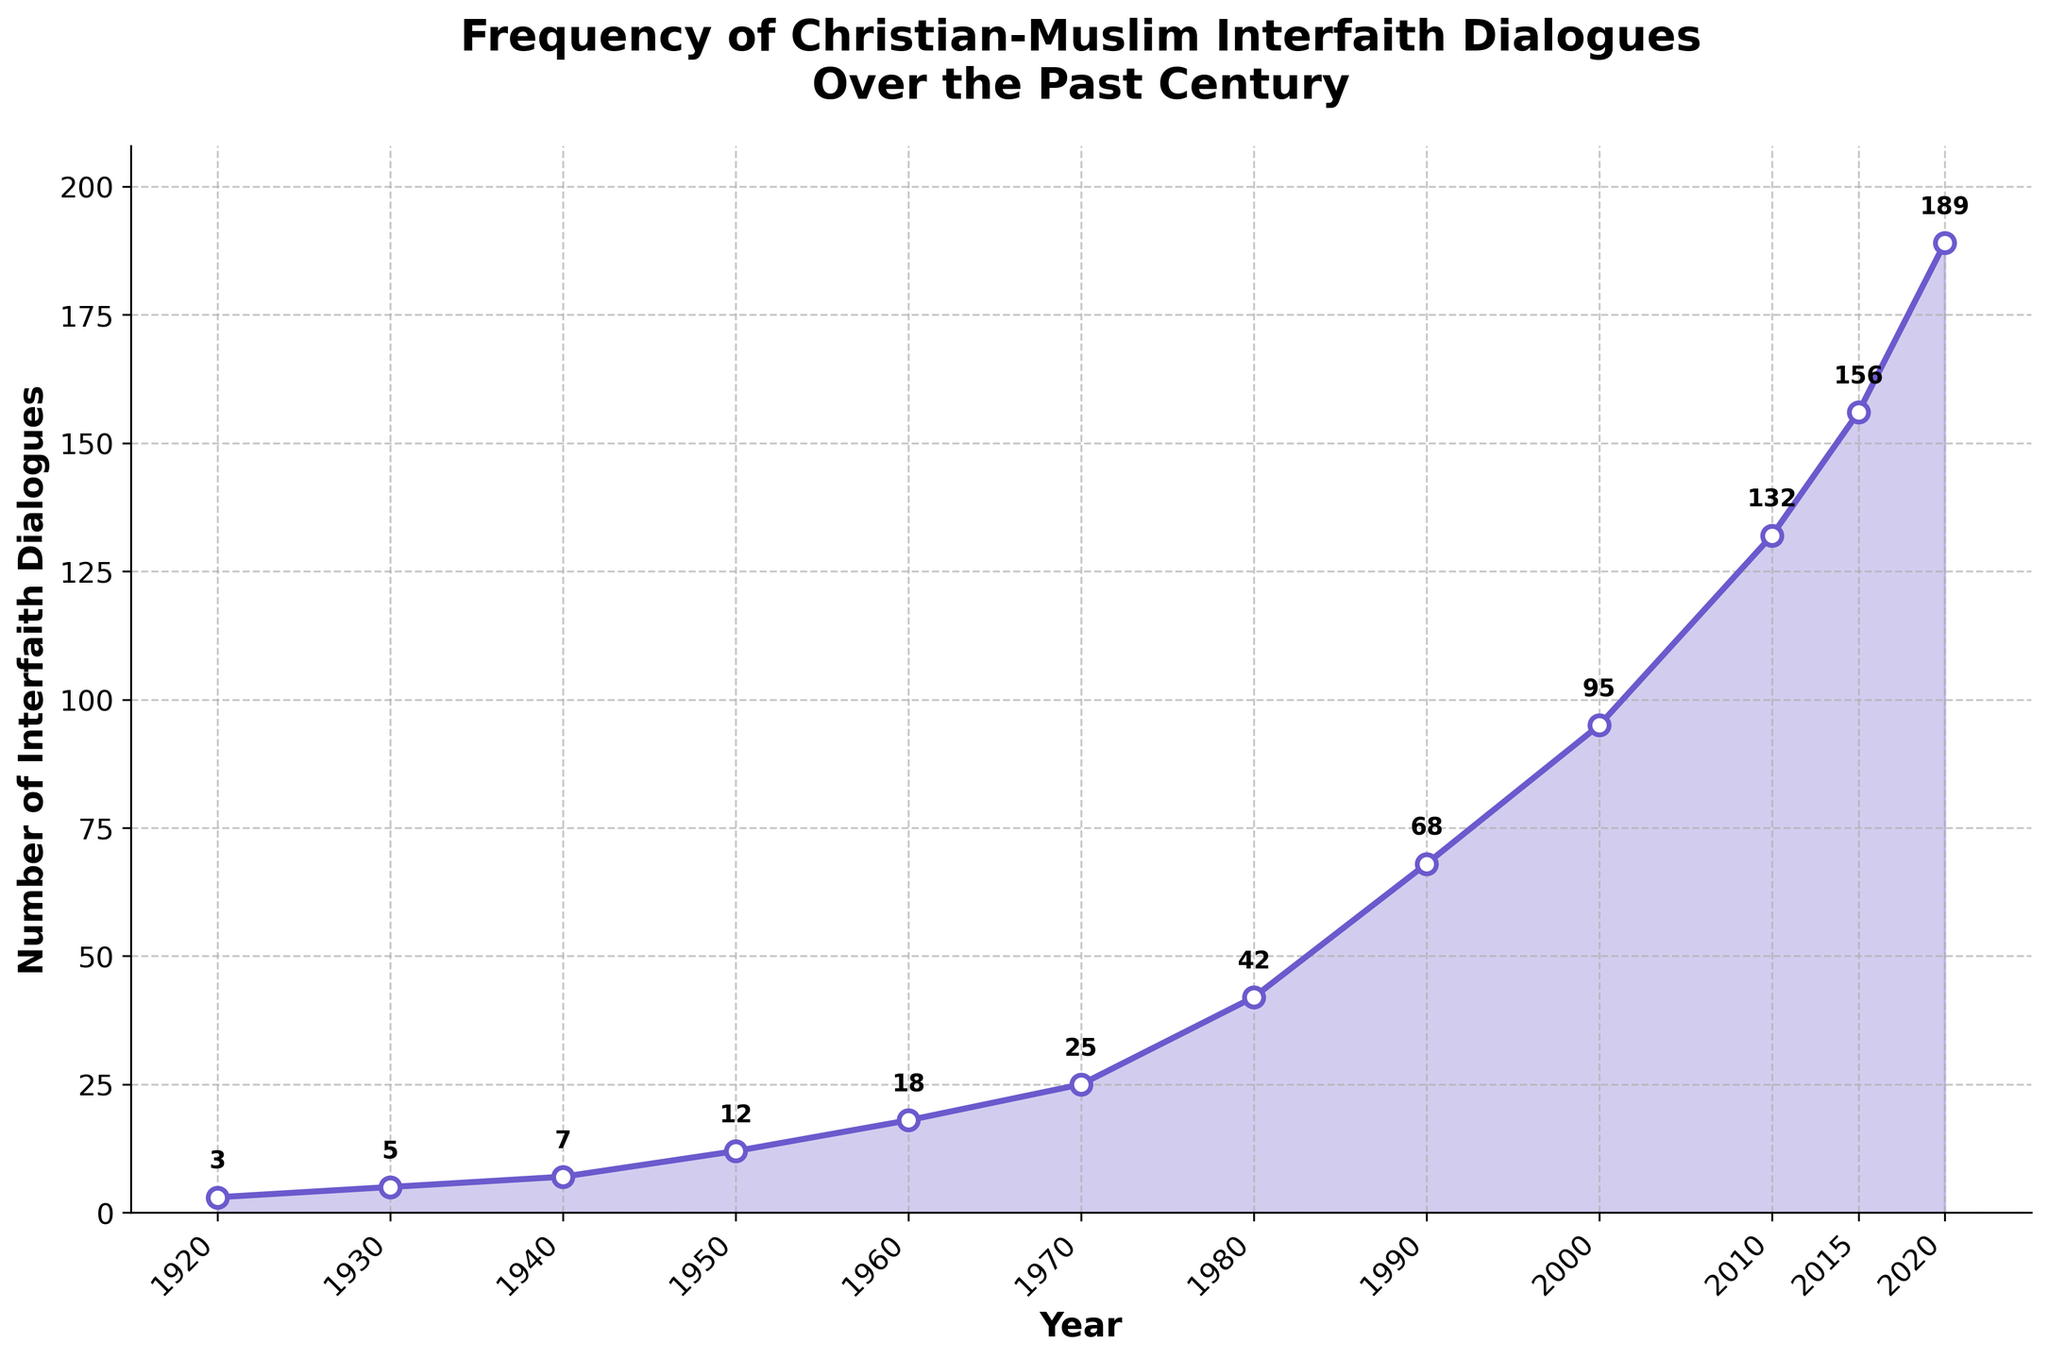What is the total number of interfaith dialogues recorded from 1920 to 2020? Summing up all the values in the 'Interfaith Dialogues' column: 3 + 5 + 7 + 12 + 18 + 25 + 42 + 68 + 95 + 132 + 156 + 189 = 752.
Answer: 752 Which decade saw the greatest increase in the number of interfaith dialogues? By how much did it increase? Checking the increase in each decade: 1930-1920 = 5-3 = 2, 1940-1930 = 7-5 = 2, 1950-1940 = 12-7 = 5, 1960-1950 = 18-12 = 6, 1970-1960 = 25-18 = 7, 1980-1970 = 42-25 = 17, 1990-1980 = 68-42 = 26, 2000-1990 = 95-68 = 27, 2010-2000 = 132-95 = 37, 2015-2010 = 156-132 = 24, 2020-2015 = 189-156 = 33. The greatest increase occurred from 2010 to 2015 with an increase of 24 dialogues.
Answer: 2010-2015, 24 How has the trend of interfaith dialogues changed between 1950 and 1980? From the graph, the dialogues in 1950 are 12, in 1960 are 18, in 1970 are 25, and in 1980 are 42. This shows a steady increase each decade: 1950-1960 = 18-12 = 6, 1960-1970 = 25-18 = 7, 1970-1980 = 42-25 = 17. So, there's a positive upward trend, with an increasing rate over the decades.
Answer: Increasing What was the percentage increase in interfaith dialogues from 2000 to 2020? Dialogues in 2000 = 95, dialogues in 2020 = 189. Percentage increase = ((189 - 95) / 95) * 100 = (94 / 95) * 100 ≈ 98.95%.
Answer: ≈ 98.95% What can be inferred about the growth of interfaith dialogues from 1980 to 2020 compared to 1920 to 1980? Dialogues in 1920 = 3, 1980 = 42, 1980 - 1920 = 42 - 3 = 39. Dialogues in 1980 = 42, 2020 = 189, 2020 - 1980 = 189 - 42 = 147. The growth was significantly higher from 1980 to 2020 (147 dialogues) compared to 1920 to 1980 (39 dialogues).
Answer: 1980-2020 saw significantly higher growth At what point did the frequency of interfaith dialogues surpass 100? From the graph, the frequency surpassed 100 dialogues between 2000 and 2010, at 2010 where it reached 132.
Answer: 2010 By how much did the number of interfaith dialogues increase between 2015 and 2020? In 2015 there were 156 dialogues and in 2020 there were 189. The increase = 189 - 156 = 33.
Answer: 33 What period recorded the most significant acceleration in the number of dialogues? Observing the steepest slope of the line in the plot, the most significant acceleration appears between 2010 and 2015. The dialogues increase by 24 in this period.
Answer: 2010-2015 What percentage of the total interfaith dialogues from 1920 to 2020 occurred in the last decade (2010-2020)? Total dialogues from 1920 to 2020 = 752. Dialogues from 2010 to 2020 = 132 + 156 + 189 = 477. Percentage = (477 / 752) * 100 ≈ 63.44%.
Answer: ≈ 63.44% How does the rate of increase in dialogues from 1970 to 1990 compare to that from 1990 to 2010? Increase from 1970 to 1990: dialogues in 1970 = 25, in 1990 = 68, increase = 68 - 25 = 43. Increase from 1990 to 2010: dialogues in 1990 = 68, in 2010 = 132, increase = 132 - 68 = 64. Rate/period for 1970-1990 = 43/20 = 2.15 per year. Rate/period for 1990-2010 = 64/20 = 3.2 per year. The rate of increase from 1990 to 2010 is higher.
Answer: 1990-2010 is higher 